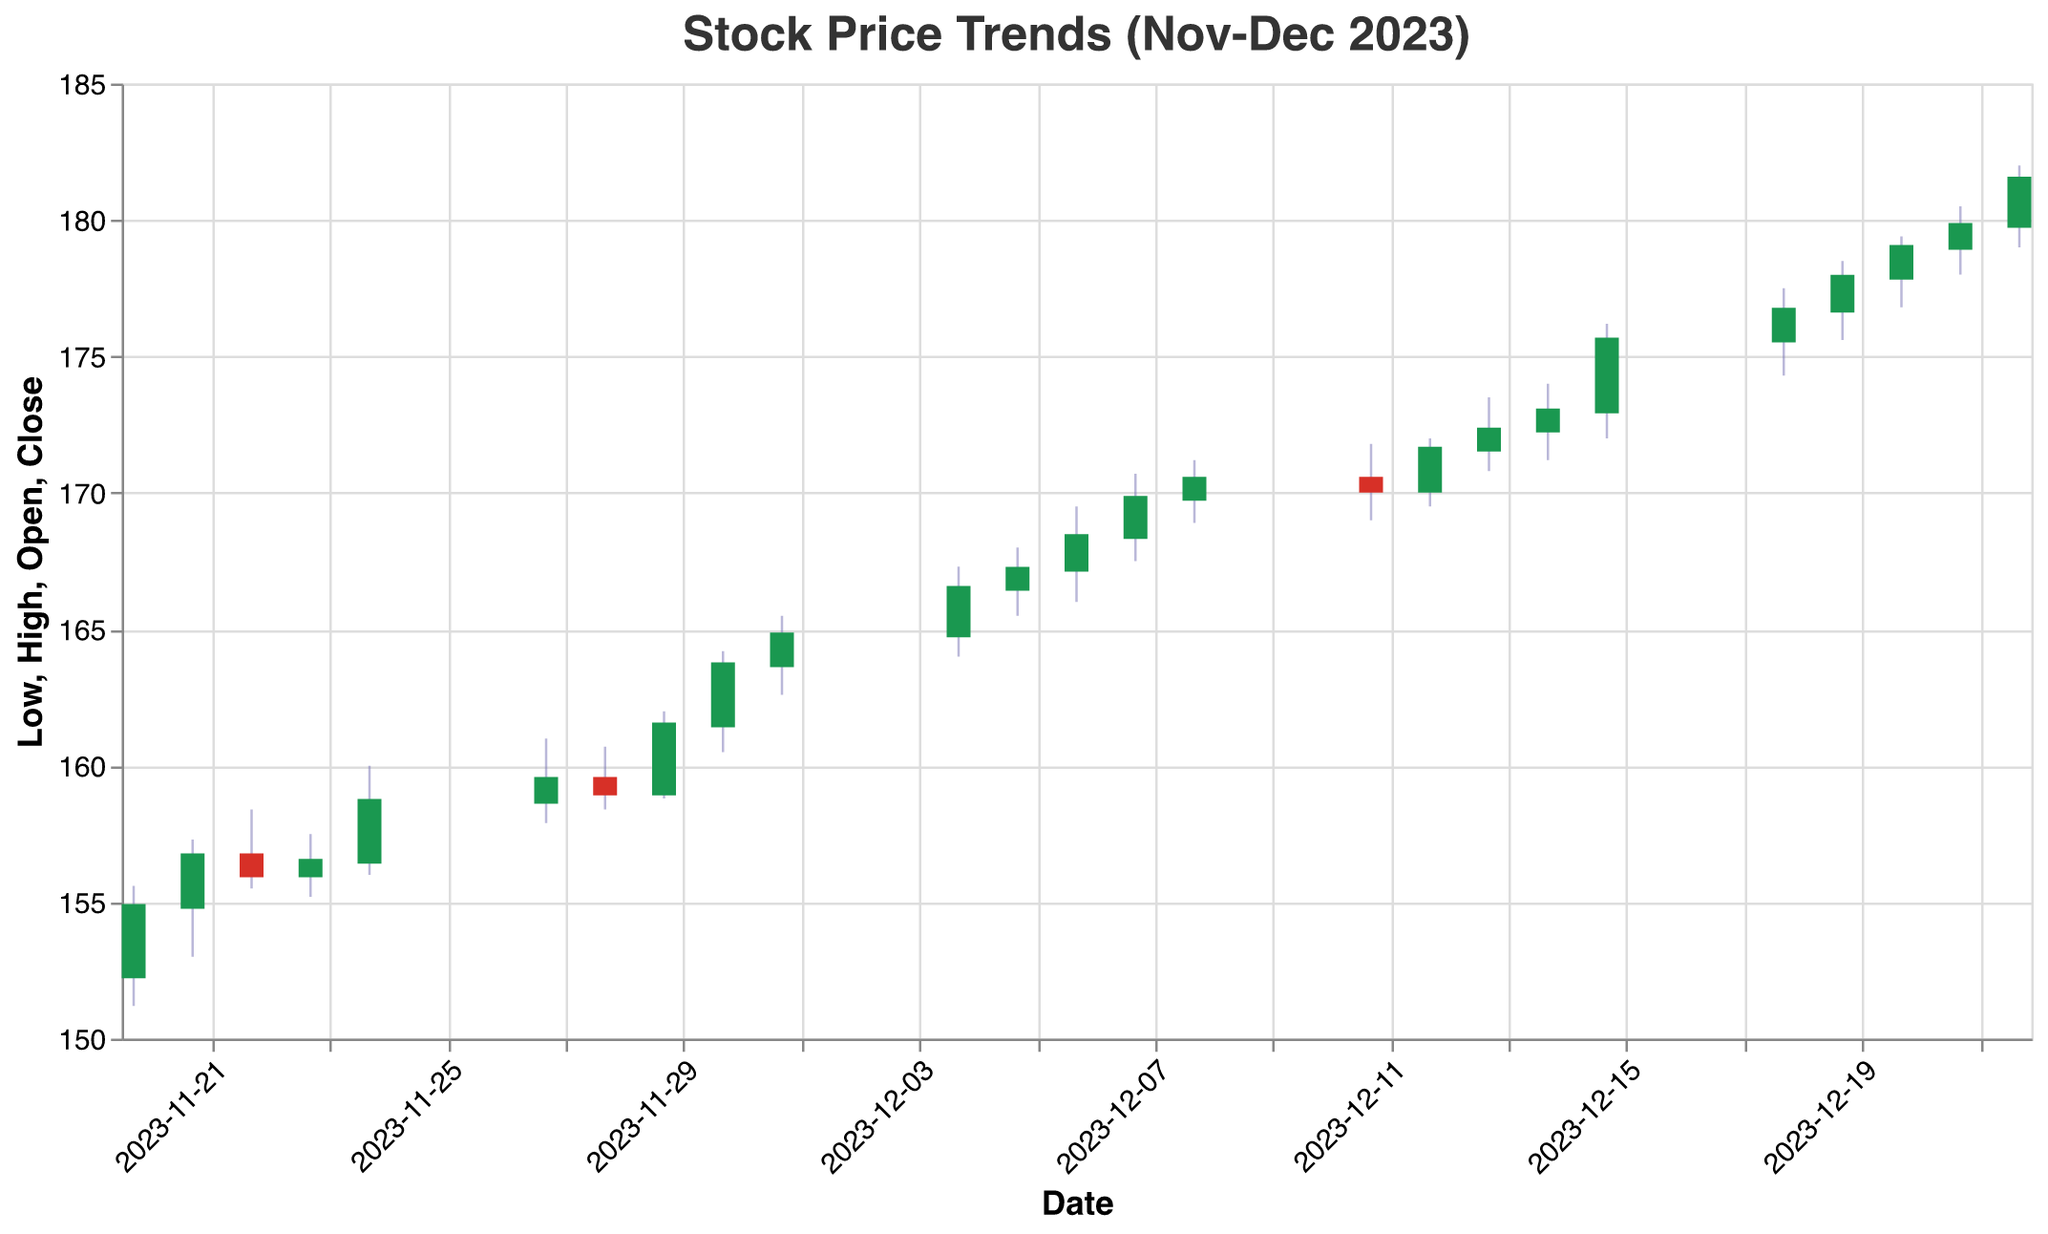How does the stock price change just before and after the U.S. Thanksgiving period? The U.S. Thanksgiving is on November 23rd. We can observe changes from November 20th to 22nd and from the 24th onward. On November 20th, the closing price was 154.85. There was a consistent rise leading to November 22nd with the closing price reaching 156. On November 24th, after the holiday, the price jumped to 158.70 and continued rising the following days.
Answer: The stock price generally increased What patterns can be observed in the stock prices throughout the beginning of December? From December 1st to December 8th, the stock prices steadily increased, with the closing price rising from 164.80 on December 1st to 170.50 on December 8th. This week-long period shows a bullish trend.
Answer: An upward trend is observed Which date has the highest trading volume, and what is it? By checking the 'Volume' axis, the highest traded volume is on December 22nd with a value of 2,150,000.
Answer: December 22nd, 2,150,000 Can we identify any sharp increases in the stock price during the holiday shopping season? Reviewing the stock prices from around the Thanksgiving period (late November) to late December reveals a notable increase. Post-Thanksgiving on November 24th, the closing price was 158.70, and it continued to rise significantly, reaching 164.80 on December 1st and further to 181.50 on December 22nd.
Answer: Yes, particularly late November to late December Compare the closing prices on December 1st and December 22nd. Which day had a higher closing price and by how much? On December 1st, the closing price was 164.80. On December 22nd, it was 181.50. The difference is 181.50 - 164.80 = 16.70.
Answer: December 22nd, by 16.70 Was there a day where the stock achieved its highest price but ended up closing lower than the opening? On December 15th, the stock opened at 173.00, reached a high of 176.20, but closed at 175.60.
Answer: Yes, December 15th Identify any periods where the stock price fell for at least two consecutive days. From November 28th to November 29th, the closing prices were 159.00 to 161.50. However, from December 11th to December 12th, the closing price dropped from 170.10 to 171.60. Upon more analysis, both are minor, but the former is invalid. Hence, from December 8th to December 11th (170.50 to 170.10), the fall is more aligned.
Answer: Yes, from December 8th to December 11th Is there a correlation between volume traded and increase in stock price in the period provided? Observing data points, particularly from early to mid-December, the volumes increase as the stock prices rise. The highest volume on December 22nd relates to a peak price. This suggests a positive correlation where higher volumes generally coincide with price rise.
Answer: Yes, there is a positive correlation 